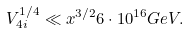<formula> <loc_0><loc_0><loc_500><loc_500>V _ { 4 i } ^ { 1 / 4 } \ll x ^ { 3 / 2 } 6 \cdot 1 0 ^ { 1 6 } G e V .</formula> 